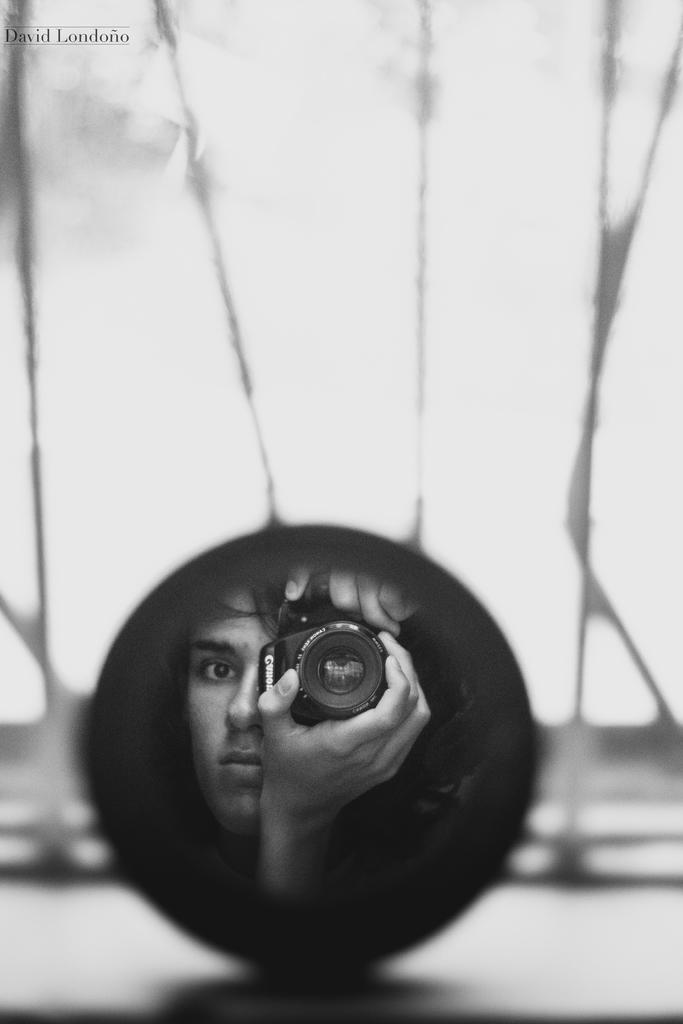Who is present in the image? There is a person in the image. What is the person holding in the image? The person is holding a camera. Can you describe the position of the camera in the image? The camera is inside a circle. What type of swing can be seen in the image? There is no swing present in the image. 